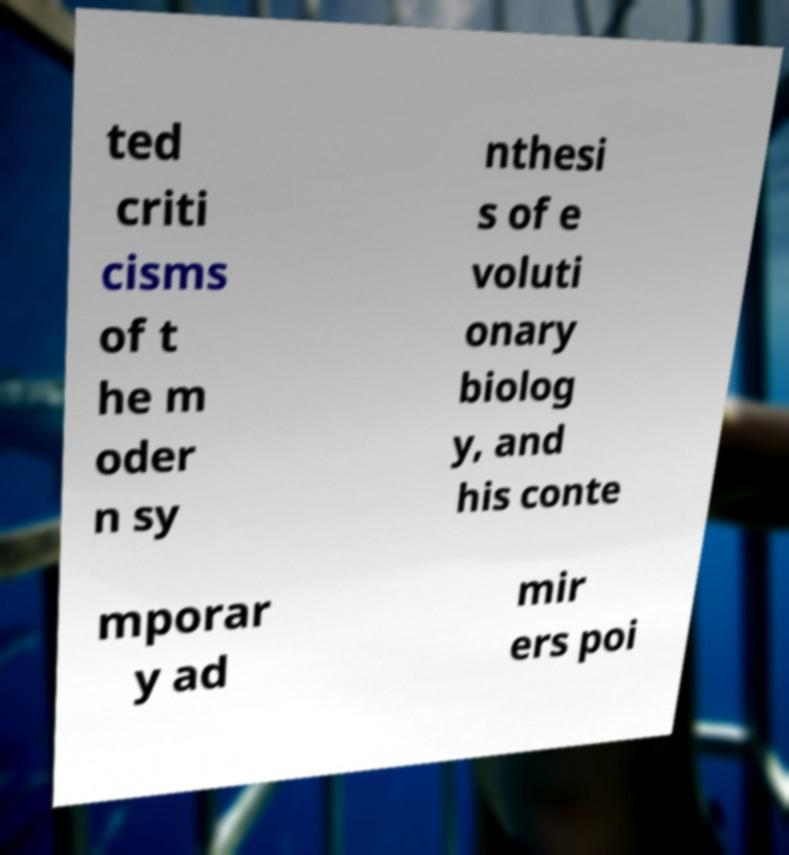Can you read and provide the text displayed in the image?This photo seems to have some interesting text. Can you extract and type it out for me? ted criti cisms of t he m oder n sy nthesi s of e voluti onary biolog y, and his conte mporar y ad mir ers poi 